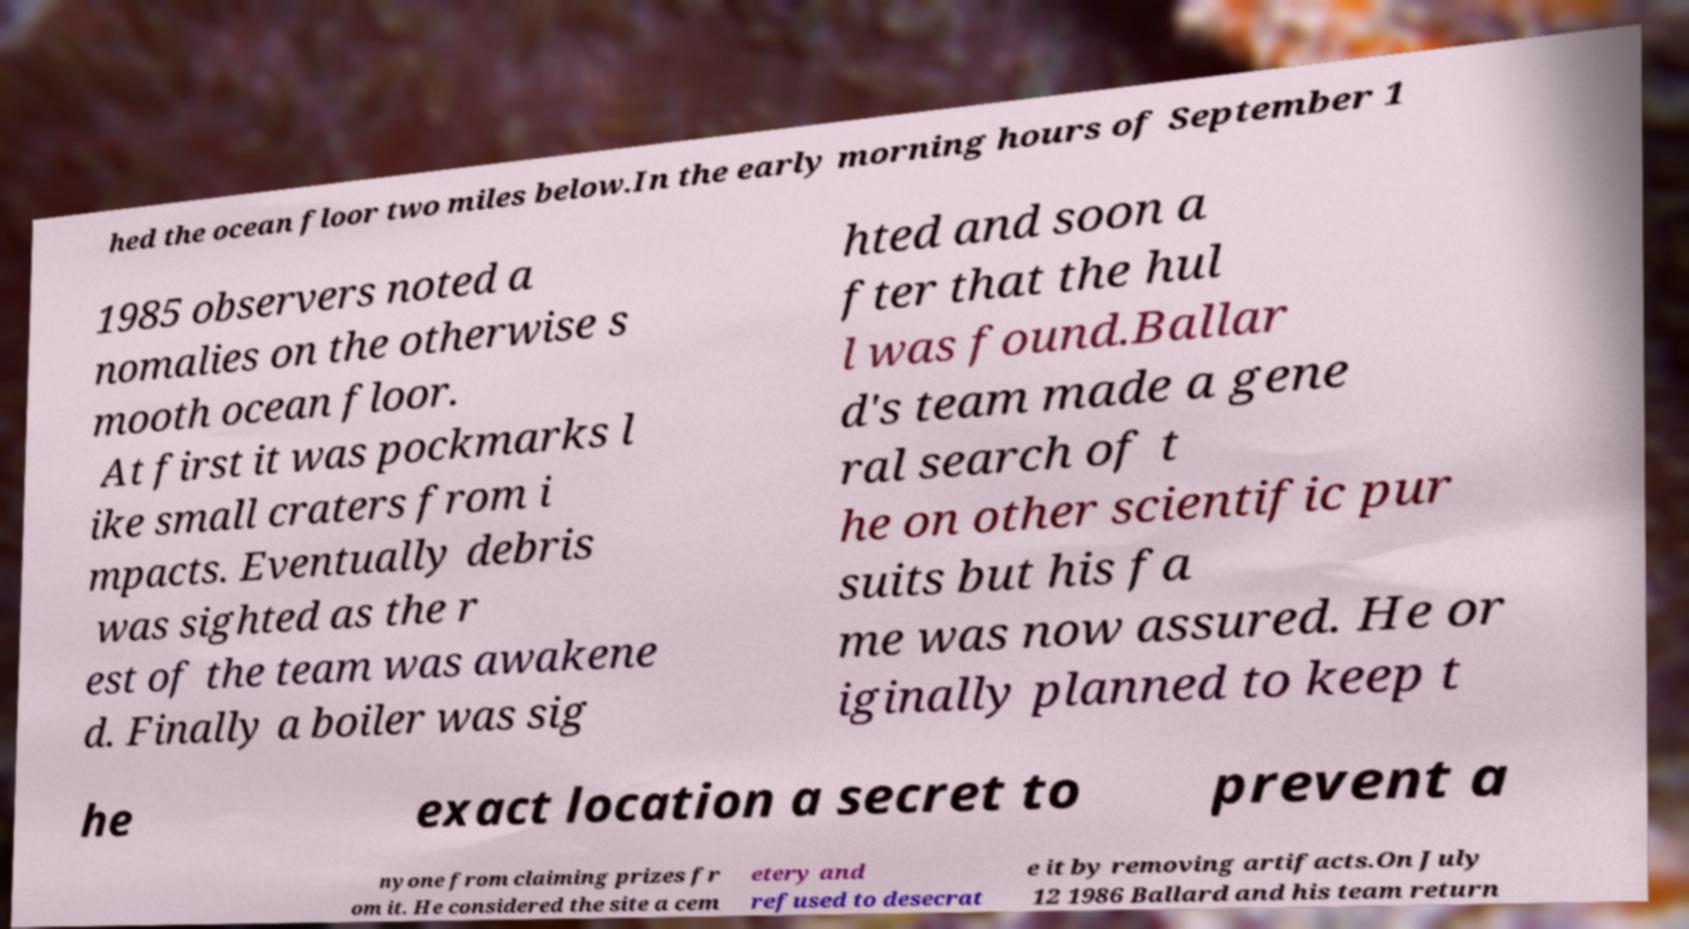For documentation purposes, I need the text within this image transcribed. Could you provide that? hed the ocean floor two miles below.In the early morning hours of September 1 1985 observers noted a nomalies on the otherwise s mooth ocean floor. At first it was pockmarks l ike small craters from i mpacts. Eventually debris was sighted as the r est of the team was awakene d. Finally a boiler was sig hted and soon a fter that the hul l was found.Ballar d's team made a gene ral search of t he on other scientific pur suits but his fa me was now assured. He or iginally planned to keep t he exact location a secret to prevent a nyone from claiming prizes fr om it. He considered the site a cem etery and refused to desecrat e it by removing artifacts.On July 12 1986 Ballard and his team return 